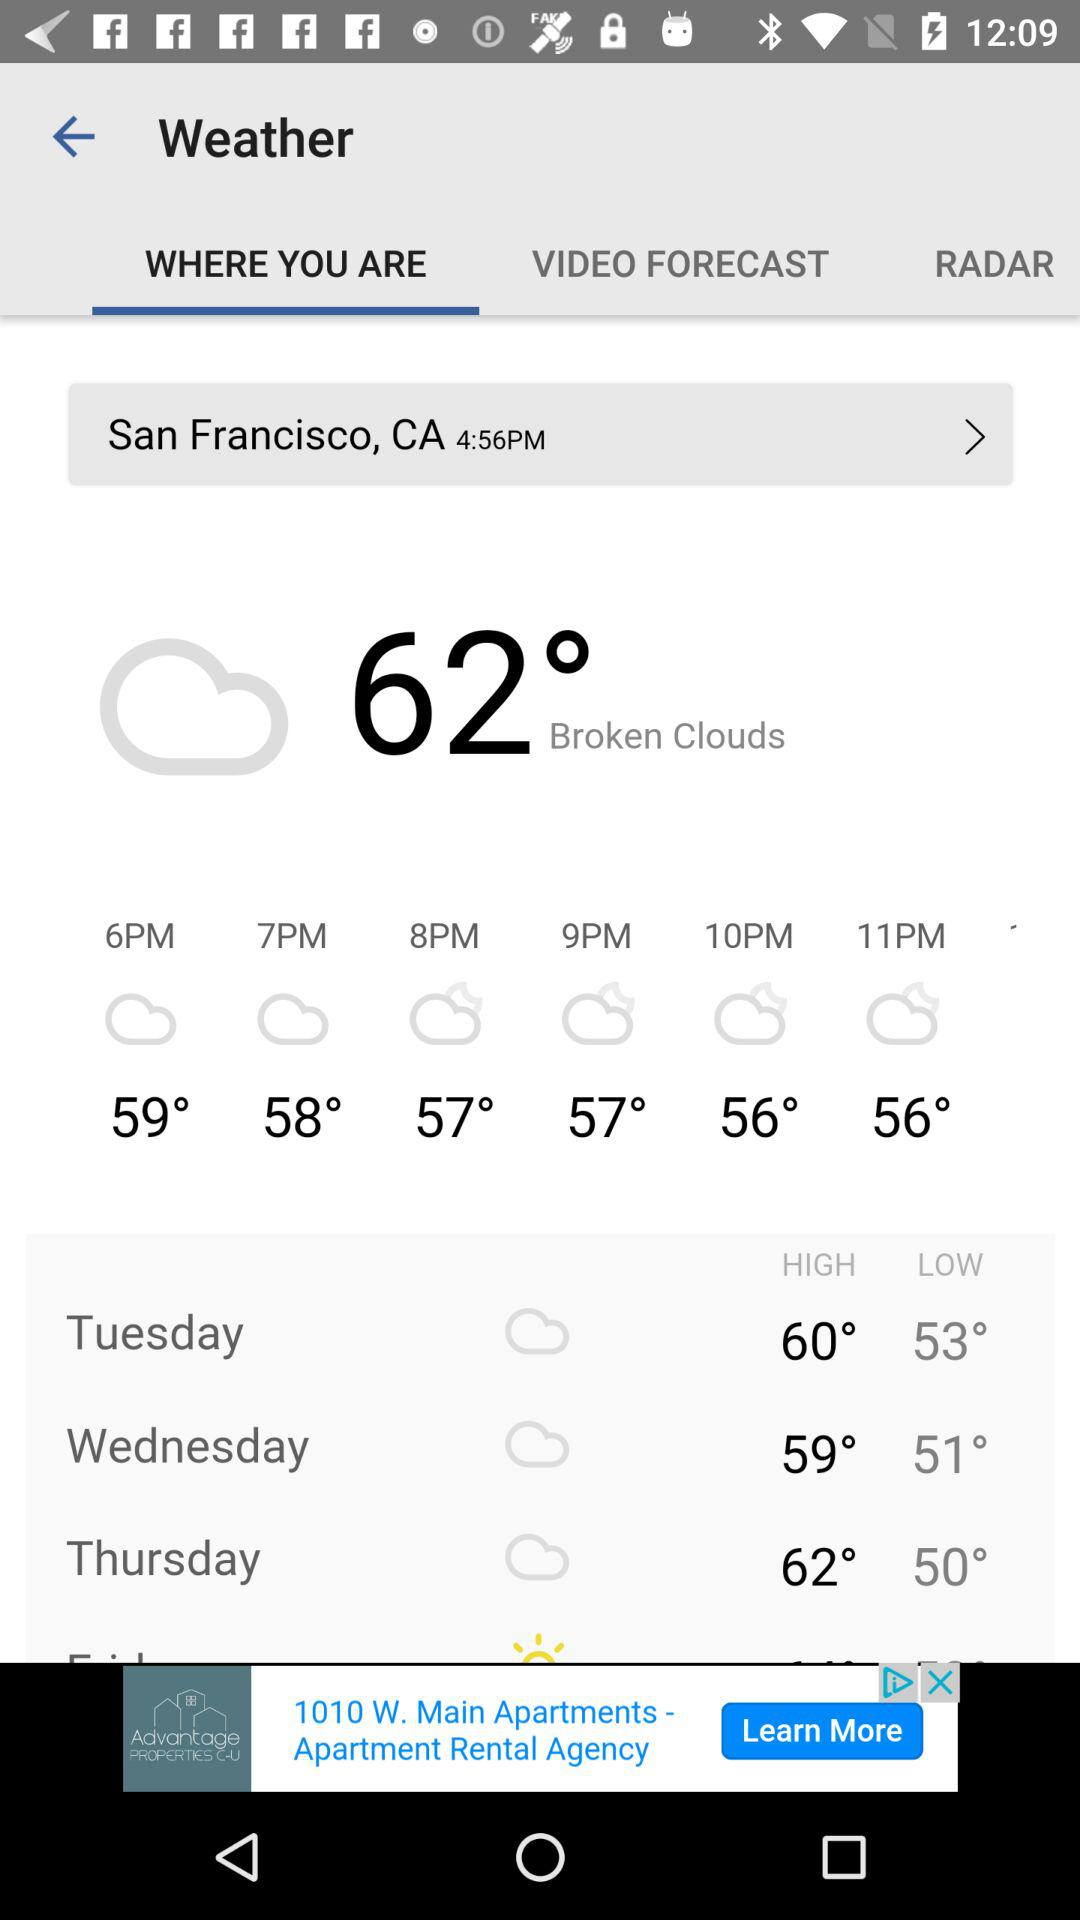What is the current temperature in degrees? The current temperature is 62°. 